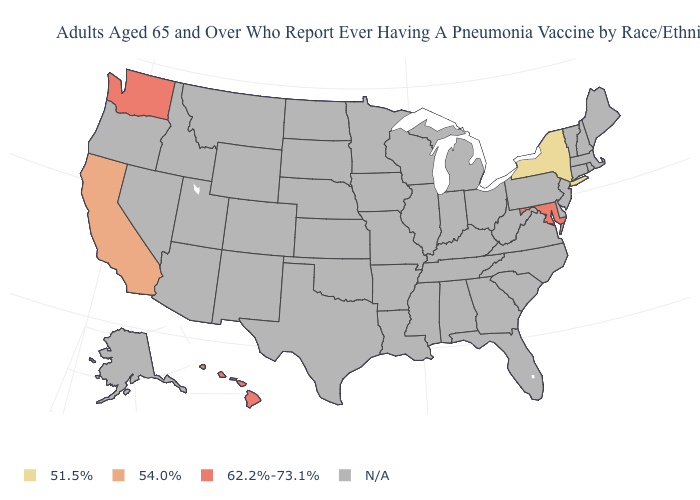Which states have the lowest value in the USA?
Give a very brief answer. New York. Is the legend a continuous bar?
Keep it brief. No. What is the value of Oklahoma?
Give a very brief answer. N/A. What is the value of Maryland?
Answer briefly. 62.2%-73.1%. What is the value of Texas?
Write a very short answer. N/A. Does California have the lowest value in the West?
Write a very short answer. Yes. What is the value of Iowa?
Be succinct. N/A. Does California have the lowest value in the USA?
Give a very brief answer. No. 